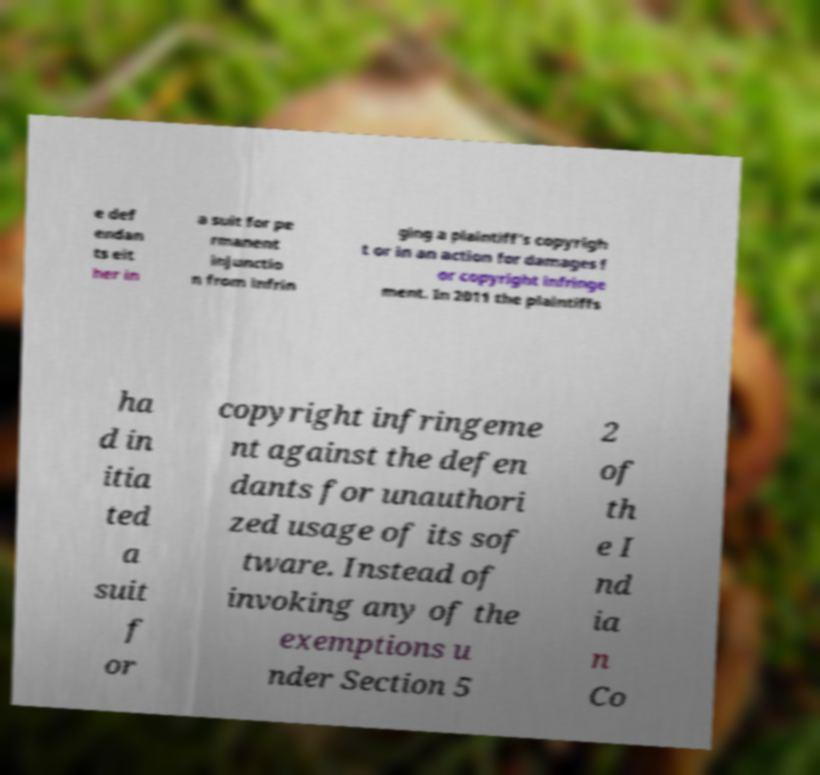Could you extract and type out the text from this image? e def endan ts eit her in a suit for pe rmanent injunctio n from infrin ging a plaintiff’s copyrigh t or in an action for damages f or copyright infringe ment. In 2011 the plaintiffs ha d in itia ted a suit f or copyright infringeme nt against the defen dants for unauthori zed usage of its sof tware. Instead of invoking any of the exemptions u nder Section 5 2 of th e I nd ia n Co 